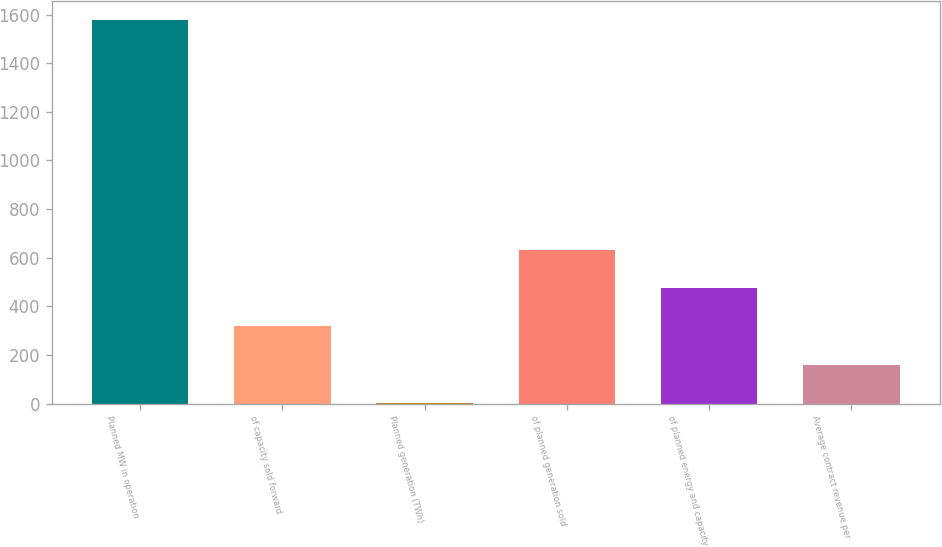Convert chart to OTSL. <chart><loc_0><loc_0><loc_500><loc_500><bar_chart><fcel>Planned MW in operation<fcel>of capacity sold forward<fcel>Planned generation (TWh)<fcel>of planned generation sold<fcel>of planned energy and capacity<fcel>Average contract revenue per<nl><fcel>1578<fcel>318<fcel>3<fcel>633<fcel>475.5<fcel>160.5<nl></chart> 